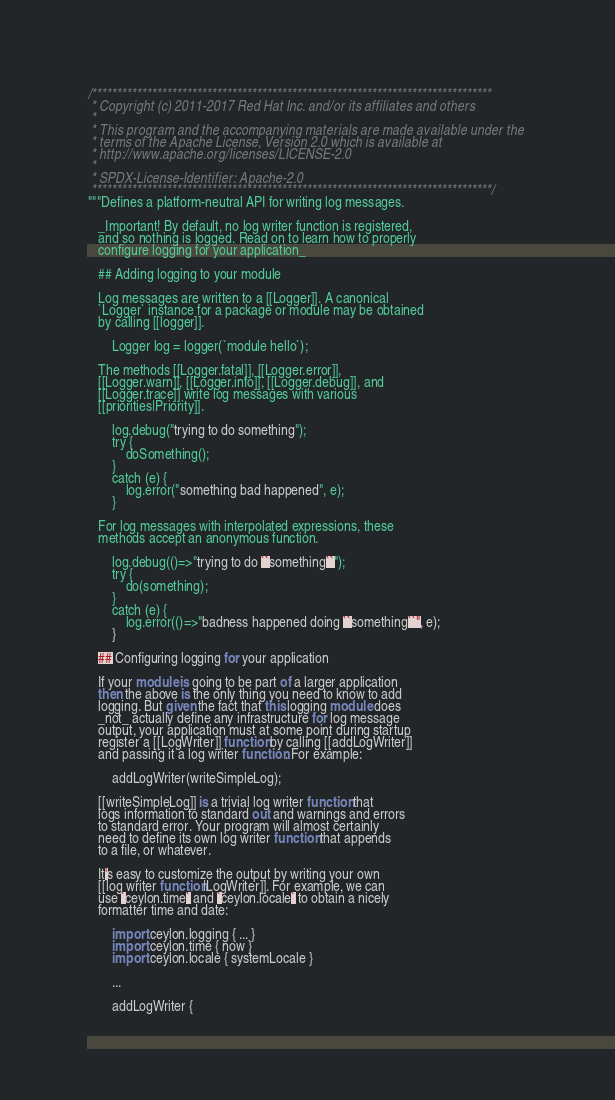<code> <loc_0><loc_0><loc_500><loc_500><_Ceylon_>/********************************************************************************
 * Copyright (c) 2011-2017 Red Hat Inc. and/or its affiliates and others
 *
 * This program and the accompanying materials are made available under the 
 * terms of the Apache License, Version 2.0 which is available at
 * http://www.apache.org/licenses/LICENSE-2.0
 *
 * SPDX-License-Identifier: Apache-2.0 
 ********************************************************************************/
"""Defines a platform-neutral API for writing log messages.
   
   _Important! By default, no log writer function is registered,
   and so nothing is logged. Read on to learn how to properly
   configure logging for your application_

   ## Adding logging to your module
   
   Log messages are written to a [[Logger]]. A canonical 
   `Logger` instance for a package or module may be obtained 
   by calling [[logger]].
   
       Logger log = logger(`module hello`);
   
   The methods [[Logger.fatal]], [[Logger.error]], 
   [[Logger.warn]], [[Logger.info]], [[Logger.debug]], and 
   [[Logger.trace]] write log messages with various
   [[priorities|Priority]].
   
       log.debug("trying to do something");
       try {
           doSomething();
       }
       catch (e) {
           log.error("something bad happened", e);
       }
   
   For log messages with interpolated expressions, these
   methods accept an anonymous function.
     
       log.debug(()=>"trying to do ``something``");
       try {
           do(something);
       }
       catch (e) {
           log.error(()=>"badness happened doing ``something``", e);
       }
   
   ## Configuring logging for your application
   
   If your module is going to be part of a larger application
   then the above is the only thing you need to know to add
   logging. But given the fact that this logging module does
   _not_ actually define any infrastructure for log message
   output, your application must at some point during startup
   register a [[LogWriter]] function by calling [[addLogWriter]]
   and passing it a log writer function. For example:
   
       addLogWriter(writeSimpleLog);
   
   [[writeSimpleLog]] is a trivial log writer function that
   logs information to standard out and warnings and errors 
   to standard error. Your program will almost certainly 
   need to define its own log writer function that appends
   to a file, or whatever. 
   
   It's easy to customize the output by writing your own
   [[log writer function|LogWriter]]. For example, we can
   use `ceylon.time` and `ceylon.locale` to obtain a nicely
   formatter time and date:
   
       import ceylon.logging { ... }
       import ceylon.time { now }
       import ceylon.locale { systemLocale }
       
       ...
       
       addLogWriter {</code> 